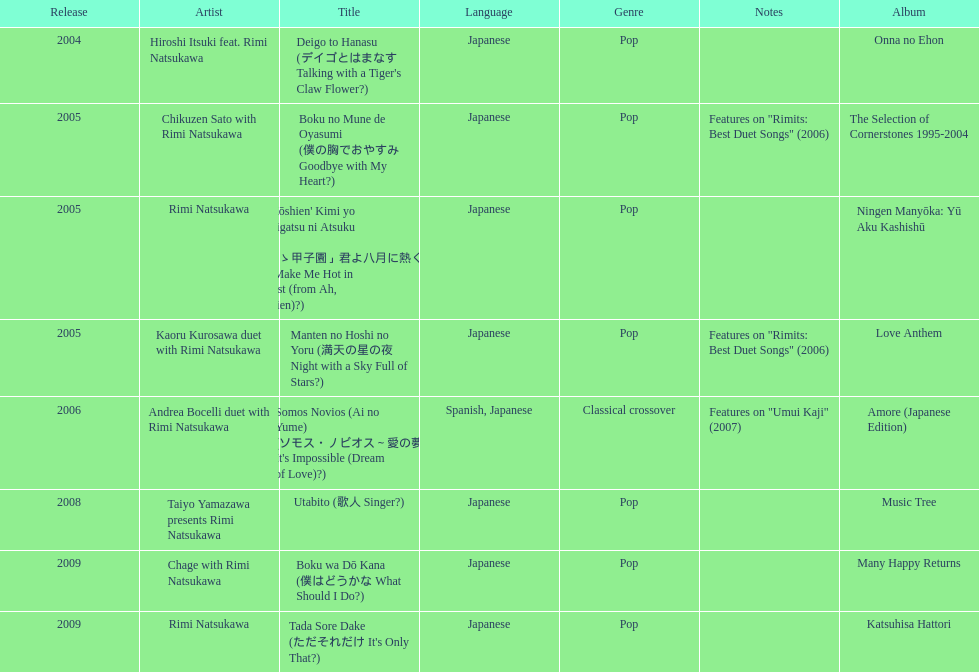Can you give me this table as a dict? {'header': ['Release', 'Artist', 'Title', 'Language', 'Genre', 'Notes', 'Album'], 'rows': [['2004', 'Hiroshi Itsuki feat. Rimi Natsukawa', "Deigo to Hanasu (デイゴとはまなす Talking with a Tiger's Claw Flower?)", 'Japanese', 'Pop', '', 'Onna no Ehon'], ['2005', 'Chikuzen Sato with Rimi Natsukawa', 'Boku no Mune de Oyasumi (僕の胸でおやすみ Goodbye with My Heart?)', 'Japanese', 'Pop', 'Features on "Rimits: Best Duet Songs" (2006)', 'The Selection of Cornerstones 1995-2004'], ['2005', 'Rimi Natsukawa', "'Aa Kōshien' Kimi yo Hachigatsu ni Atsuku Nare (「あゝ甲子園」君よ八月に熱くなれ You Make Me Hot in August (from Ah, Kōshien)?)", 'Japanese', 'Pop', '', 'Ningen Manyōka: Yū Aku Kashishū'], ['2005', 'Kaoru Kurosawa duet with Rimi Natsukawa', 'Manten no Hoshi no Yoru (満天の星の夜 Night with a Sky Full of Stars?)', 'Japanese', 'Pop', 'Features on "Rimits: Best Duet Songs" (2006)', 'Love Anthem'], ['2006', 'Andrea Bocelli duet with Rimi Natsukawa', "Somos Novios (Ai no Yume) (ソモス・ノビオス～愛の夢 It's Impossible (Dream of Love)?)", 'Spanish, Japanese', 'Classical crossover', 'Features on "Umui Kaji" (2007)', 'Amore (Japanese Edition)'], ['2008', 'Taiyo Yamazawa presents Rimi Natsukawa', 'Utabito (歌人 Singer?)', 'Japanese', 'Pop', '', 'Music Tree'], ['2009', 'Chage with Rimi Natsukawa', 'Boku wa Dō Kana (僕はどうかな What Should I Do?)', 'Japanese', 'Pop', '', 'Many Happy Returns'], ['2009', 'Rimi Natsukawa', "Tada Sore Dake (ただそれだけ It's Only That?)", 'Japanese', 'Pop', '', 'Katsuhisa Hattori']]} How many other appearance did this artist make in 2005? 3. 